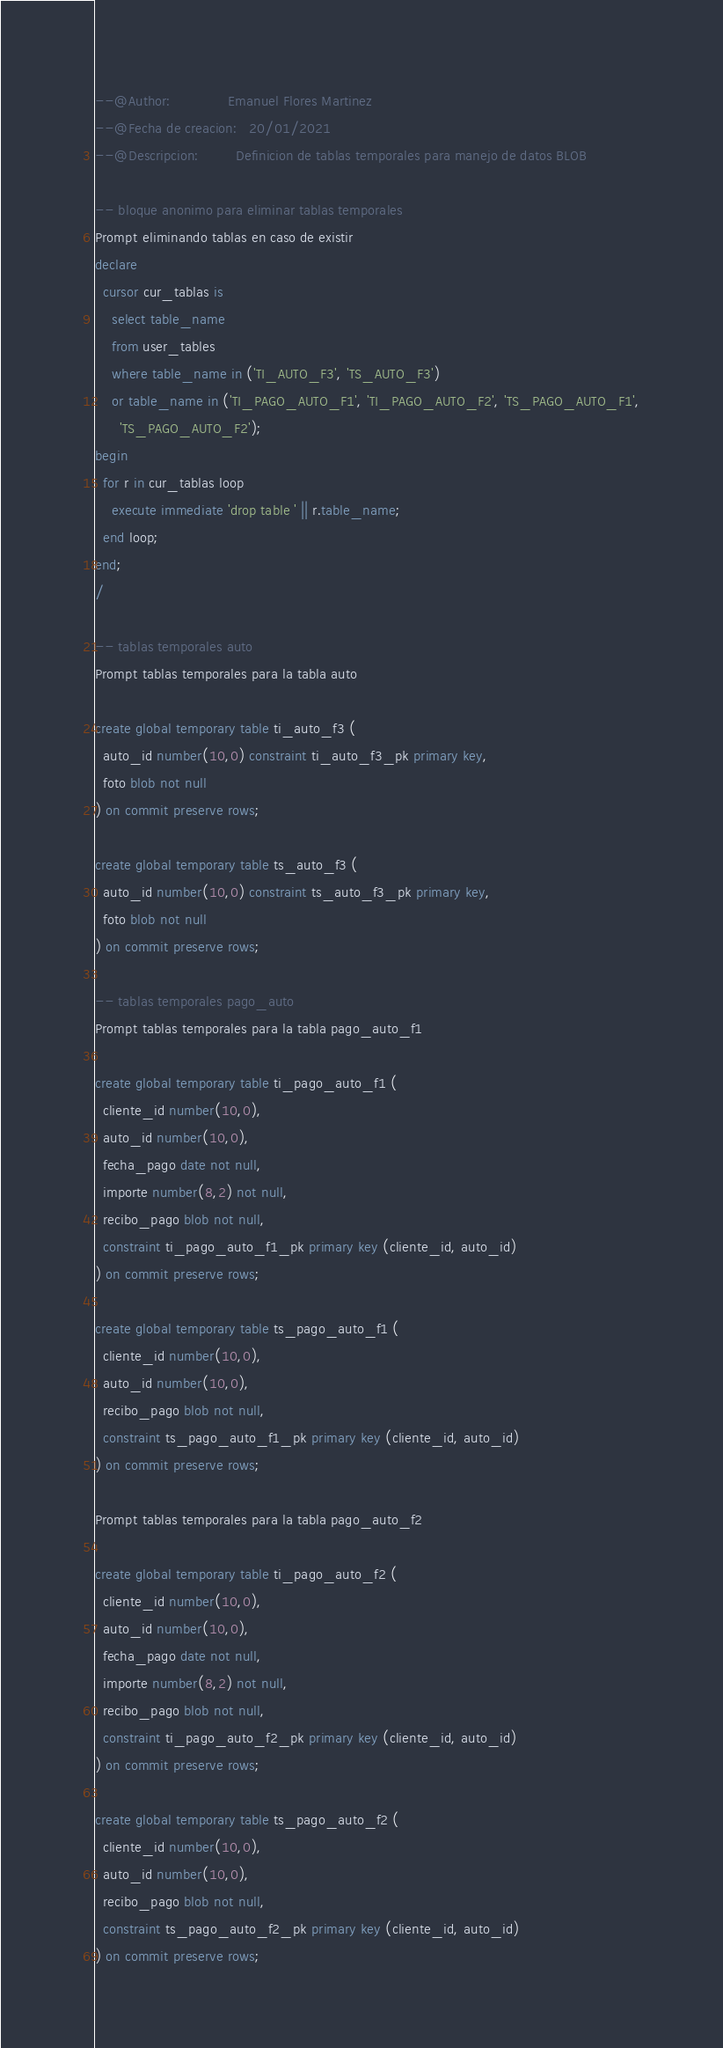Convert code to text. <code><loc_0><loc_0><loc_500><loc_500><_SQL_>--@Author:              Emanuel Flores Martinez 
--@Fecha de creacion:   20/01/2021
--@Descripcion:         Definicion de tablas temporales para manejo de datos BLOB

-- bloque anonimo para eliminar tablas temporales
Prompt eliminando tablas en caso de existir
declare
  cursor cur_tablas is
    select table_name
    from user_tables
    where table_name in ('TI_AUTO_F3', 'TS_AUTO_F3')
    or table_name in ('TI_PAGO_AUTO_F1', 'TI_PAGO_AUTO_F2', 'TS_PAGO_AUTO_F1',
      'TS_PAGO_AUTO_F2');
begin
  for r in cur_tablas loop
    execute immediate 'drop table ' || r.table_name;
  end loop;
end;
/

-- tablas temporales auto
Prompt tablas temporales para la tabla auto

create global temporary table ti_auto_f3 (
  auto_id number(10,0) constraint ti_auto_f3_pk primary key,
  foto blob not null
) on commit preserve rows;

create global temporary table ts_auto_f3 (
  auto_id number(10,0) constraint ts_auto_f3_pk primary key,
  foto blob not null
) on commit preserve rows;

-- tablas temporales pago_auto
Prompt tablas temporales para la tabla pago_auto_f1

create global temporary table ti_pago_auto_f1 (
  cliente_id number(10,0),
  auto_id number(10,0),
  fecha_pago date not null,
  importe number(8,2) not null,
  recibo_pago blob not null,
  constraint ti_pago_auto_f1_pk primary key (cliente_id, auto_id)
) on commit preserve rows;

create global temporary table ts_pago_auto_f1 (
  cliente_id number(10,0),
  auto_id number(10,0),
  recibo_pago blob not null,
  constraint ts_pago_auto_f1_pk primary key (cliente_id, auto_id)
) on commit preserve rows;

Prompt tablas temporales para la tabla pago_auto_f2

create global temporary table ti_pago_auto_f2 (
  cliente_id number(10,0),
  auto_id number(10,0),
  fecha_pago date not null,
  importe number(8,2) not null,
  recibo_pago blob not null,
  constraint ti_pago_auto_f2_pk primary key (cliente_id, auto_id)
) on commit preserve rows;

create global temporary table ts_pago_auto_f2 (
  cliente_id number(10,0),
  auto_id number(10,0),
  recibo_pago blob not null,
  constraint ts_pago_auto_f2_pk primary key (cliente_id, auto_id)
) on commit preserve rows;</code> 